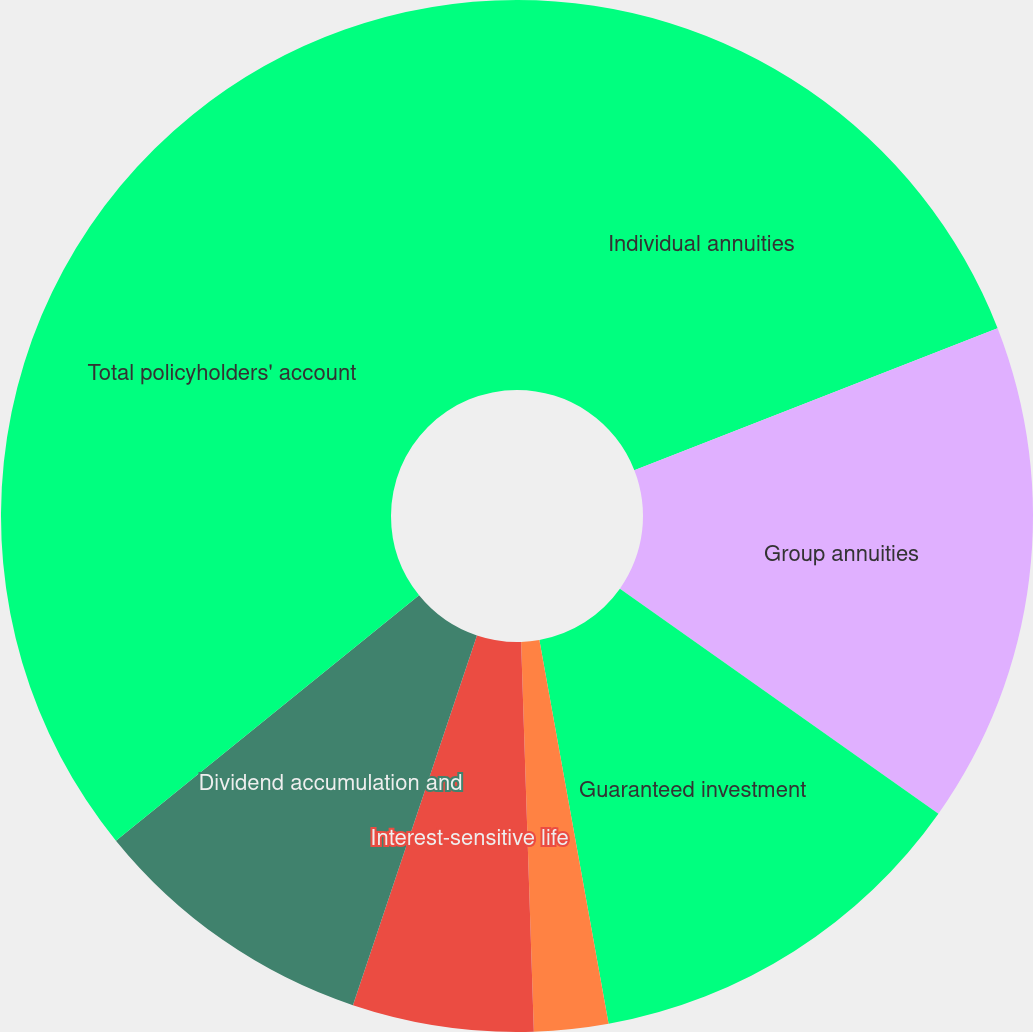Convert chart. <chart><loc_0><loc_0><loc_500><loc_500><pie_chart><fcel>Individual annuities<fcel>Group annuities<fcel>Guaranteed investment<fcel>Funding agreements<fcel>Interest-sensitive life<fcel>Dividend accumulation and<fcel>Total policyholders' account<nl><fcel>19.07%<fcel>15.72%<fcel>12.37%<fcel>2.32%<fcel>5.67%<fcel>9.02%<fcel>35.83%<nl></chart> 